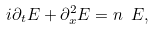Convert formula to latex. <formula><loc_0><loc_0><loc_500><loc_500>i \partial _ { t } E + \partial _ { x } ^ { 2 } E = n \ E ,</formula> 